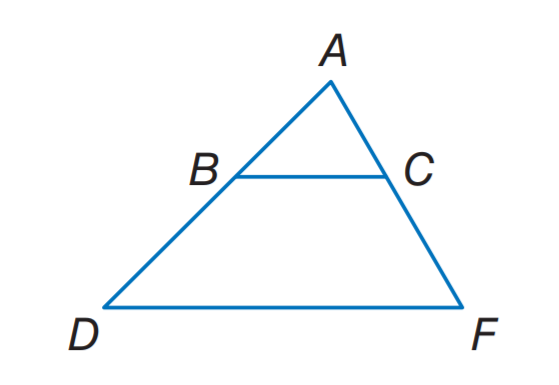What geometrical properties can be inferred from the image regarding the sides and angles? The image presents a trapezoid with a pair of parallel sides, BC and DF, which indicates that the angles connected by these sides are supplementary. Moreover, because we have an isosceles trapezoid, the non-parallel sides, AB and CF, are congruent as are the angles at vertices B and C. Additionally, triangles ABD and ACF are similar due to angle-angle similarity, and this allows for proportional reasoning between their corresponding sides. The base angles of the isosceles triangles ABD and ACF are equal, ensuring symmetrical properties within the shape. 